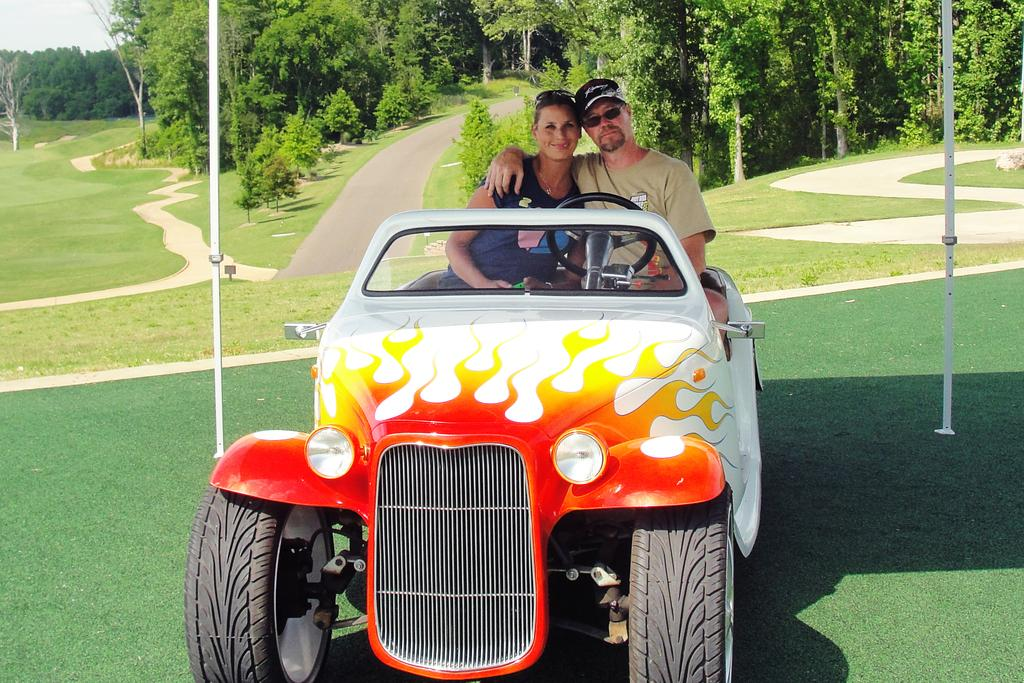What is the main subject of the image? The main subject of the image is a vehicle. Who or what is inside the vehicle? Two persons are seated in the vehicle. What can be seen in the background of the image? There are metal rods and trees in the background of the image. What activity is the father doing with the vehicle in the image? There is no mention of a father in the image, and the activity of the persons seated in the vehicle is not specified. 